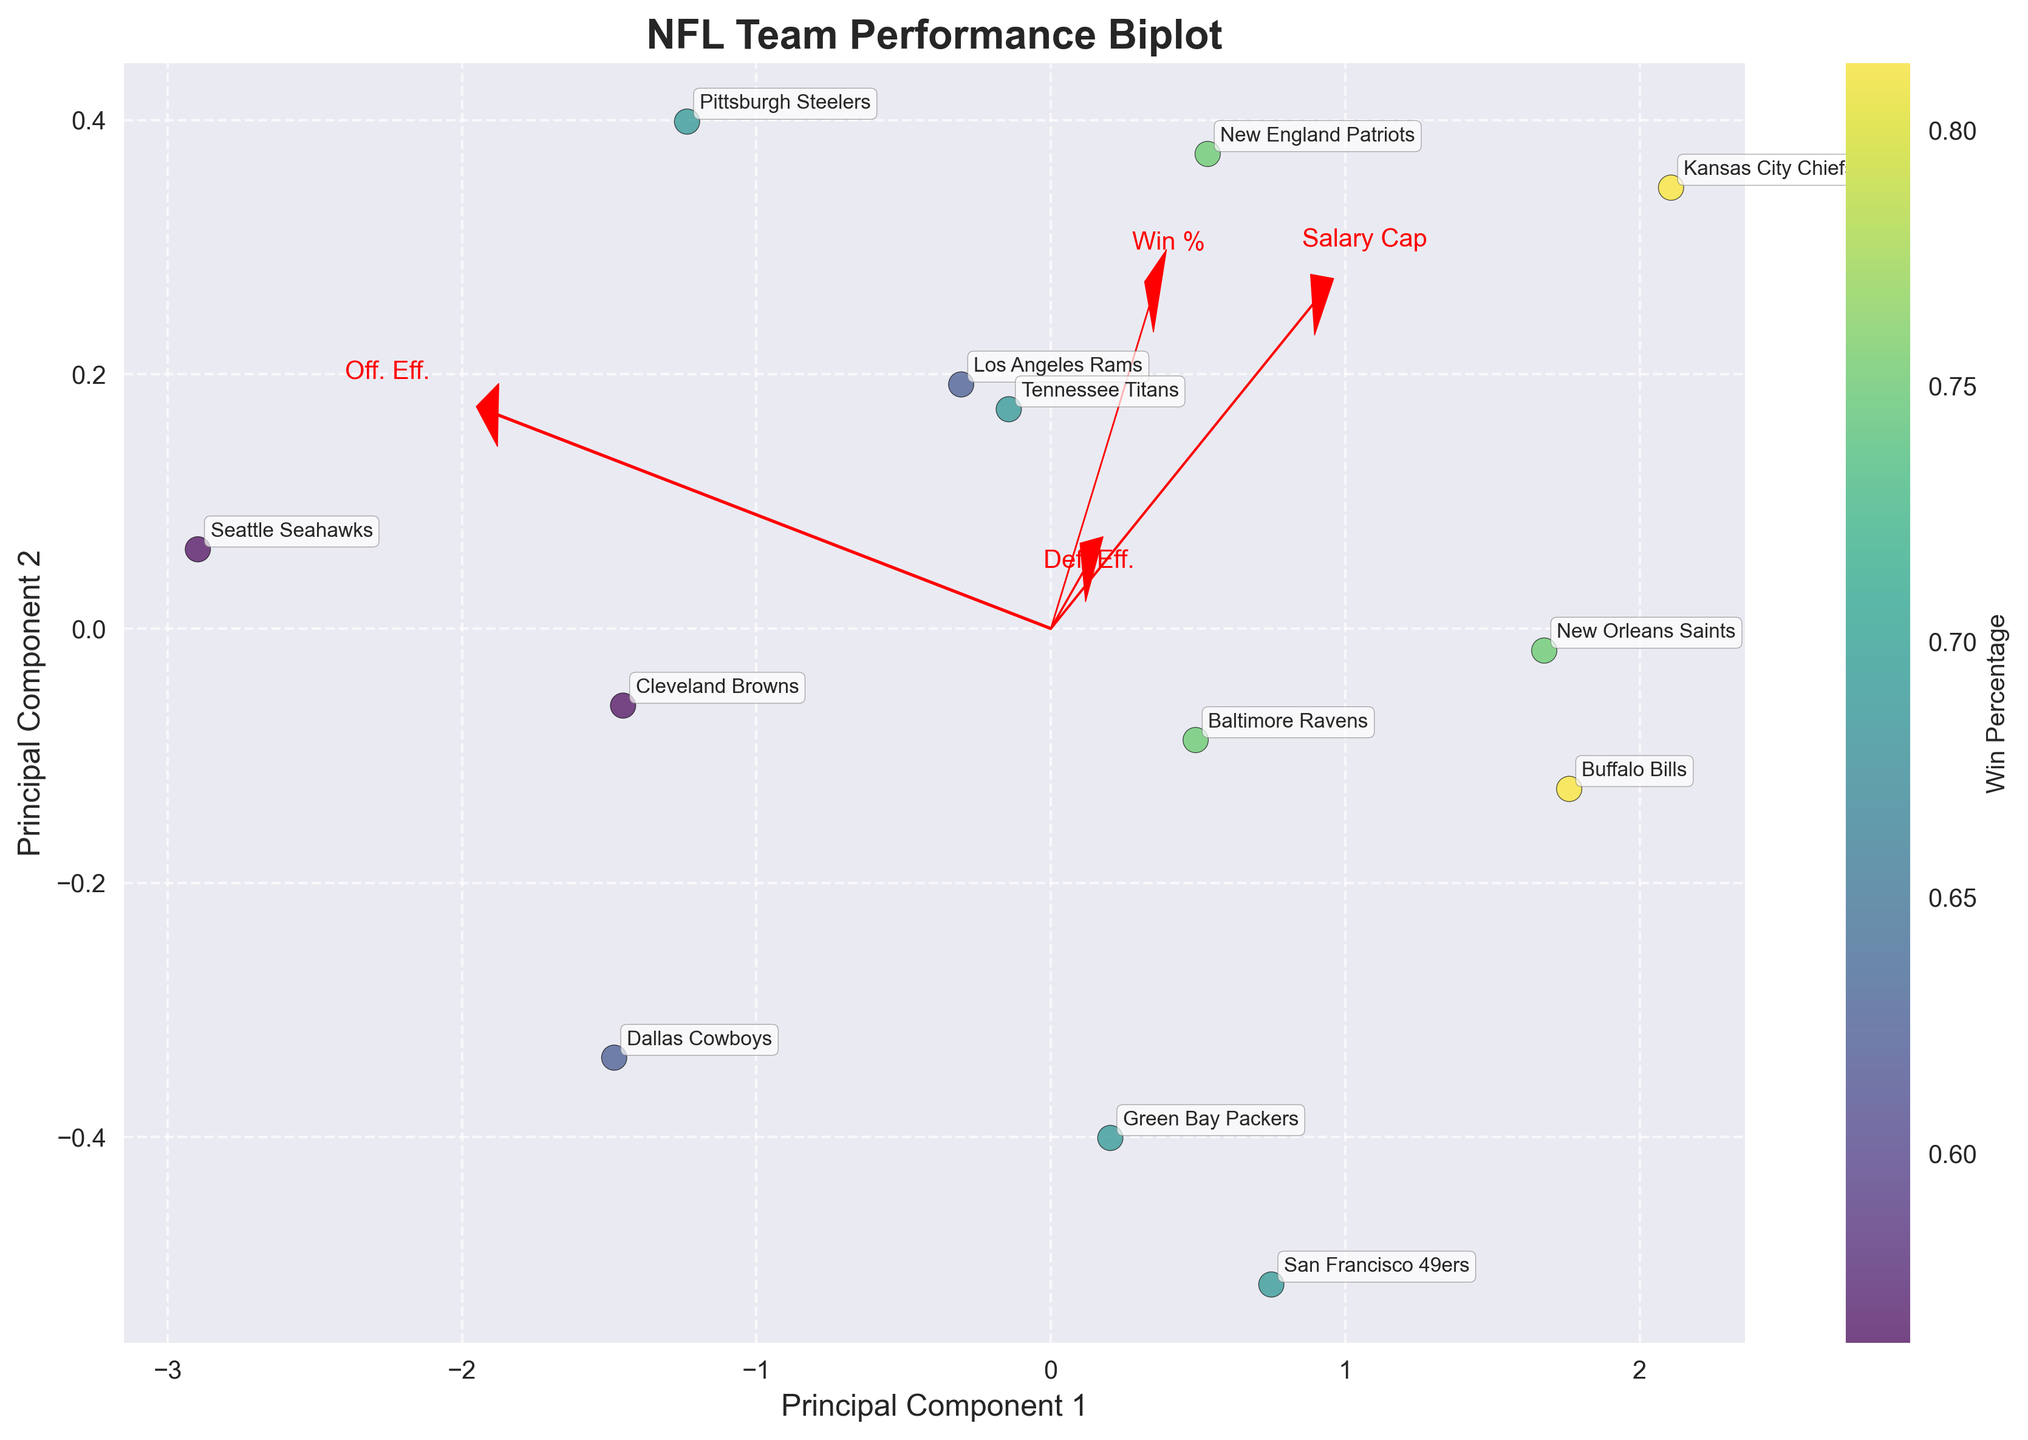What are the axes labeled as? The x-axis is labeled as 'Principal Component 1', and the y-axis is labeled as 'Principal Component 2'. You can see these labels directly on the axes of the plot.
Answer: 'Principal Component 1' and 'Principal Component 2' How many NFL teams are displayed in the plot? There are 13 data points on the chart. Each point represents one NFL team, and their team names are annotated near the data points.
Answer: 13 Which team has the highest win percentage based on the color intensity on the plot? The Kansas City Chiefs and the Buffalo Bills have the highest win percentage, represented by the darkest intensity on the color map.
Answer: Kansas City Chiefs and Buffalo Bills What features are represented by the red arrows in the biplot? The red arrows represent Salary Cap, Win Percentage, Offensive Efficiency, and Defensive Efficiency. The arrows indicate directions and contributions of these features to the principal components.
Answer: Salary Cap, Win Percentage, Offensive Efficiency, Defensive Efficiency Which two teams are closest to each other in the biplot space? The Pittsburgh Steelers and the Tennessee Titans are the closest to each other, as their data points are nearest in the biplot.
Answer: Pittsburgh Steelers and Tennessee Titans What is the average 'Win Percentage' of the teams included in the biplot? To find the average, sum the win percentages of all teams and divide by the number of teams: (0.750 + 0.688 + 0.813 + 0.625 + 0.688 + 0.750 + 0.563 + 0.688 + 0.750 + 0.813 + 0.625 + 0.688 + 0.563) / 13 = 8.964 / 13 = 0.689.
Answer: 0.689 Which principal component is more influenced by 'Offensive Efficiency'? The length and direction of the arrows represent the influence. The 'Offensive Efficiency' arrow is more aligned with Principal Component 1, indicating a stronger influence on PC1.
Answer: Principal Component 1 How does the 'Defense Efficiency' vector compare to the 'Salary Cap' vector in terms of angle and direction? The 'Defensive Efficiency' vector has a different angle, pointing more towards Principal Component 2, whereas the 'Salary Cap' vector is more aligned with Principal Component 1, showing distinct directions.
Answer: Different angles and directions Which team has a high 'Offensive Efficiency' but a comparatively lower 'Win Percentage'? The Green Bay Packers have a high Offensive Efficiency (88.1) but a comparatively lower Win Percentage (0.688).
Answer: Green Bay Packers What can you infer about the relationship between salary cap spending and winning percentage from the biplot? The biplot shows that salary cap spending (Salary Cap) and winning percentage (Win %) are positively correlated, as both vectors point in similar directions, indicating that teams spending more on salary cap tend to have higher win percentages.
Answer: Positive correlation 